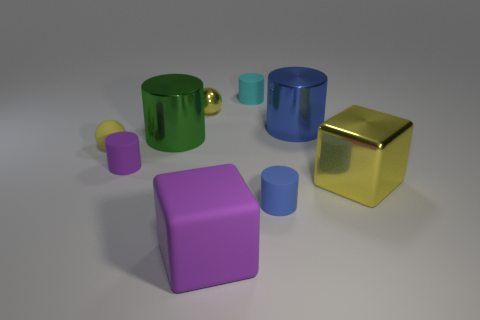What is the shape of the rubber object that is the same color as the small shiny ball?
Your answer should be compact. Sphere. What color is the metallic ball?
Give a very brief answer. Yellow. Does the yellow metallic thing to the right of the tiny metal sphere have the same shape as the tiny yellow rubber thing?
Your response must be concise. No. How many things are either big things to the left of the tiny yellow metal sphere or blue cylinders?
Your response must be concise. 3. Are there any big red things that have the same shape as the small yellow matte object?
Your response must be concise. No. The green thing that is the same size as the blue metal object is what shape?
Offer a very short reply. Cylinder. What is the shape of the purple matte thing that is behind the tiny cylinder in front of the large cube that is right of the tiny cyan object?
Ensure brevity in your answer.  Cylinder. Does the small blue object have the same shape as the cyan thing that is behind the tiny blue cylinder?
Your answer should be compact. Yes. What number of small objects are either purple rubber things or cyan rubber objects?
Provide a short and direct response. 2. Is there a yellow matte sphere of the same size as the yellow matte thing?
Give a very brief answer. No. 